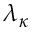Convert formula to latex. <formula><loc_0><loc_0><loc_500><loc_500>\lambda _ { \kappa }</formula> 